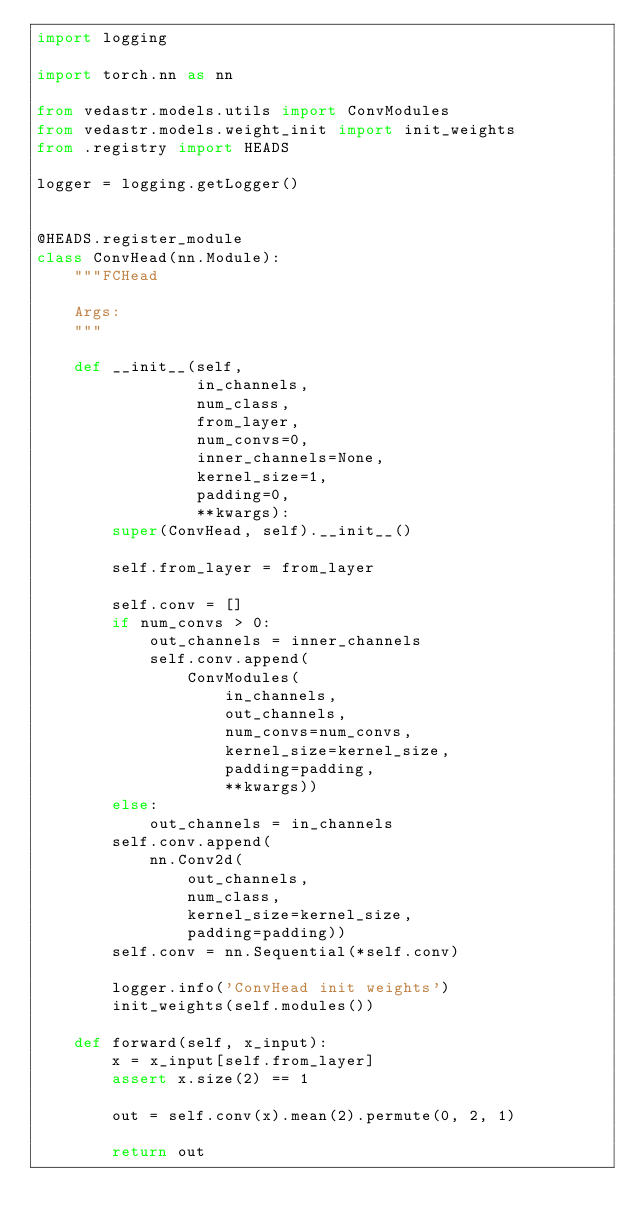Convert code to text. <code><loc_0><loc_0><loc_500><loc_500><_Python_>import logging

import torch.nn as nn

from vedastr.models.utils import ConvModules
from vedastr.models.weight_init import init_weights
from .registry import HEADS

logger = logging.getLogger()


@HEADS.register_module
class ConvHead(nn.Module):
    """FCHead

    Args:
    """

    def __init__(self,
                 in_channels,
                 num_class,
                 from_layer,
                 num_convs=0,
                 inner_channels=None,
                 kernel_size=1,
                 padding=0,
                 **kwargs):
        super(ConvHead, self).__init__()

        self.from_layer = from_layer

        self.conv = []
        if num_convs > 0:
            out_channels = inner_channels
            self.conv.append(
                ConvModules(
                    in_channels,
                    out_channels,
                    num_convs=num_convs,
                    kernel_size=kernel_size,
                    padding=padding,
                    **kwargs))
        else:
            out_channels = in_channels
        self.conv.append(
            nn.Conv2d(
                out_channels,
                num_class,
                kernel_size=kernel_size,
                padding=padding))
        self.conv = nn.Sequential(*self.conv)

        logger.info('ConvHead init weights')
        init_weights(self.modules())

    def forward(self, x_input):
        x = x_input[self.from_layer]
        assert x.size(2) == 1

        out = self.conv(x).mean(2).permute(0, 2, 1)

        return out
</code> 